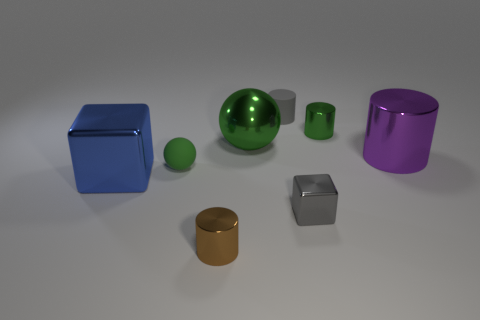Are there more tiny gray metallic cubes left of the small block than purple objects left of the tiny brown metallic thing?
Your answer should be compact. No. The brown thing is what size?
Give a very brief answer. Small. There is a large thing that is right of the small gray metallic cube; is it the same color as the large metal cube?
Offer a terse response. No. Are there any other things that have the same shape as the big blue metallic thing?
Offer a very short reply. Yes. Are there any green matte things behind the ball behind the purple metallic object?
Provide a short and direct response. No. Are there fewer big metallic cylinders to the left of the big green object than purple metal objects on the left side of the blue thing?
Your response must be concise. No. There is a cylinder in front of the metal cube behind the shiny cube that is right of the big block; what size is it?
Provide a succinct answer. Small. There is a green ball right of the brown metallic cylinder; does it have the same size as the large purple cylinder?
Keep it short and to the point. Yes. What number of other objects are the same material as the gray cylinder?
Keep it short and to the point. 1. Is the number of cylinders greater than the number of tiny blocks?
Make the answer very short. Yes. 